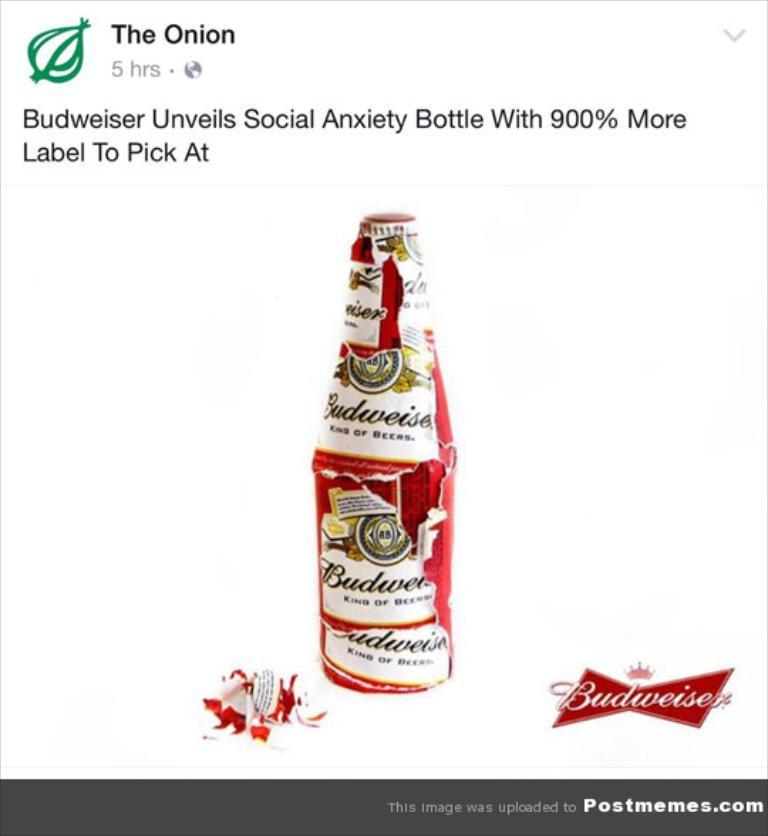<image>
Present a compact description of the photo's key features. A satire post from The Onion about a Budweiser bottle. 